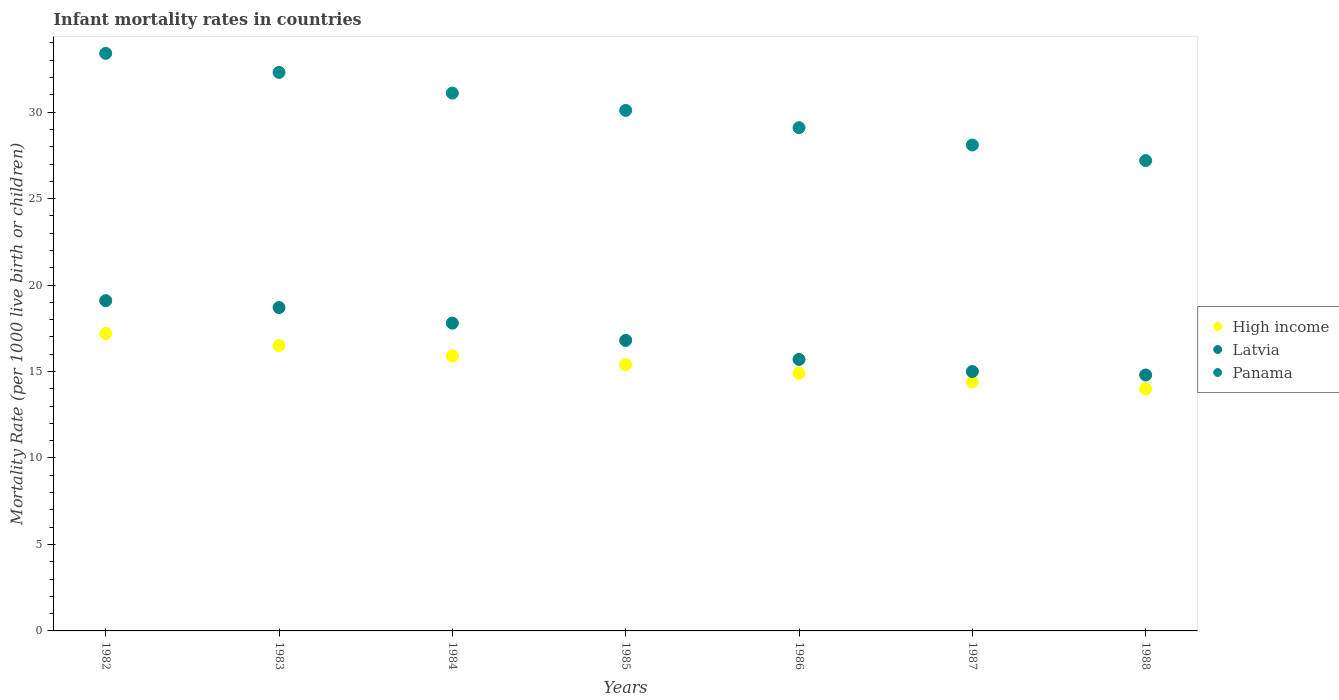What is the infant mortality rate in Latvia in 1987?
Your answer should be very brief. 15. Across all years, what is the maximum infant mortality rate in Panama?
Your response must be concise. 33.4. Across all years, what is the minimum infant mortality rate in High income?
Your response must be concise. 14. In which year was the infant mortality rate in Panama minimum?
Your answer should be very brief. 1988. What is the total infant mortality rate in Latvia in the graph?
Ensure brevity in your answer.  117.9. What is the difference between the infant mortality rate in Panama in 1982 and that in 1983?
Give a very brief answer. 1.1. What is the difference between the infant mortality rate in High income in 1984 and the infant mortality rate in Latvia in 1986?
Offer a very short reply. 0.2. What is the average infant mortality rate in High income per year?
Give a very brief answer. 15.47. What is the ratio of the infant mortality rate in Latvia in 1983 to that in 1984?
Offer a very short reply. 1.05. Is the infant mortality rate in High income in 1983 less than that in 1988?
Provide a succinct answer. No. Is the difference between the infant mortality rate in Panama in 1983 and 1984 greater than the difference between the infant mortality rate in Latvia in 1983 and 1984?
Your answer should be compact. Yes. What is the difference between the highest and the second highest infant mortality rate in Panama?
Make the answer very short. 1.1. What is the difference between the highest and the lowest infant mortality rate in Panama?
Provide a succinct answer. 6.2. In how many years, is the infant mortality rate in High income greater than the average infant mortality rate in High income taken over all years?
Offer a very short reply. 3. Is it the case that in every year, the sum of the infant mortality rate in High income and infant mortality rate in Latvia  is greater than the infant mortality rate in Panama?
Provide a succinct answer. Yes. Does the infant mortality rate in Panama monotonically increase over the years?
Provide a succinct answer. No. Is the infant mortality rate in High income strictly greater than the infant mortality rate in Latvia over the years?
Offer a very short reply. No. What is the difference between two consecutive major ticks on the Y-axis?
Ensure brevity in your answer.  5. Are the values on the major ticks of Y-axis written in scientific E-notation?
Make the answer very short. No. Does the graph contain grids?
Keep it short and to the point. No. How many legend labels are there?
Offer a terse response. 3. What is the title of the graph?
Provide a succinct answer. Infant mortality rates in countries. What is the label or title of the X-axis?
Offer a very short reply. Years. What is the label or title of the Y-axis?
Keep it short and to the point. Mortality Rate (per 1000 live birth or children). What is the Mortality Rate (per 1000 live birth or children) in Latvia in 1982?
Ensure brevity in your answer.  19.1. What is the Mortality Rate (per 1000 live birth or children) in Panama in 1982?
Offer a very short reply. 33.4. What is the Mortality Rate (per 1000 live birth or children) of High income in 1983?
Offer a very short reply. 16.5. What is the Mortality Rate (per 1000 live birth or children) in Panama in 1983?
Make the answer very short. 32.3. What is the Mortality Rate (per 1000 live birth or children) in High income in 1984?
Your answer should be compact. 15.9. What is the Mortality Rate (per 1000 live birth or children) in Panama in 1984?
Your answer should be compact. 31.1. What is the Mortality Rate (per 1000 live birth or children) in Latvia in 1985?
Ensure brevity in your answer.  16.8. What is the Mortality Rate (per 1000 live birth or children) of Panama in 1985?
Give a very brief answer. 30.1. What is the Mortality Rate (per 1000 live birth or children) in Panama in 1986?
Keep it short and to the point. 29.1. What is the Mortality Rate (per 1000 live birth or children) of High income in 1987?
Your response must be concise. 14.4. What is the Mortality Rate (per 1000 live birth or children) in Latvia in 1987?
Offer a terse response. 15. What is the Mortality Rate (per 1000 live birth or children) of Panama in 1987?
Your answer should be very brief. 28.1. What is the Mortality Rate (per 1000 live birth or children) in Latvia in 1988?
Offer a very short reply. 14.8. What is the Mortality Rate (per 1000 live birth or children) in Panama in 1988?
Your response must be concise. 27.2. Across all years, what is the maximum Mortality Rate (per 1000 live birth or children) of Panama?
Offer a terse response. 33.4. Across all years, what is the minimum Mortality Rate (per 1000 live birth or children) in Panama?
Provide a short and direct response. 27.2. What is the total Mortality Rate (per 1000 live birth or children) of High income in the graph?
Offer a very short reply. 108.3. What is the total Mortality Rate (per 1000 live birth or children) of Latvia in the graph?
Offer a very short reply. 117.9. What is the total Mortality Rate (per 1000 live birth or children) of Panama in the graph?
Your answer should be compact. 211.3. What is the difference between the Mortality Rate (per 1000 live birth or children) in High income in 1982 and that in 1984?
Give a very brief answer. 1.3. What is the difference between the Mortality Rate (per 1000 live birth or children) in Latvia in 1982 and that in 1984?
Provide a succinct answer. 1.3. What is the difference between the Mortality Rate (per 1000 live birth or children) of Panama in 1982 and that in 1984?
Provide a succinct answer. 2.3. What is the difference between the Mortality Rate (per 1000 live birth or children) in Latvia in 1982 and that in 1985?
Your response must be concise. 2.3. What is the difference between the Mortality Rate (per 1000 live birth or children) in Panama in 1982 and that in 1985?
Offer a terse response. 3.3. What is the difference between the Mortality Rate (per 1000 live birth or children) of Latvia in 1982 and that in 1986?
Your response must be concise. 3.4. What is the difference between the Mortality Rate (per 1000 live birth or children) in High income in 1982 and that in 1987?
Give a very brief answer. 2.8. What is the difference between the Mortality Rate (per 1000 live birth or children) in Panama in 1982 and that in 1987?
Offer a very short reply. 5.3. What is the difference between the Mortality Rate (per 1000 live birth or children) of High income in 1982 and that in 1988?
Make the answer very short. 3.2. What is the difference between the Mortality Rate (per 1000 live birth or children) in Panama in 1982 and that in 1988?
Your response must be concise. 6.2. What is the difference between the Mortality Rate (per 1000 live birth or children) in Latvia in 1983 and that in 1984?
Your answer should be very brief. 0.9. What is the difference between the Mortality Rate (per 1000 live birth or children) in Panama in 1983 and that in 1984?
Make the answer very short. 1.2. What is the difference between the Mortality Rate (per 1000 live birth or children) in High income in 1983 and that in 1985?
Give a very brief answer. 1.1. What is the difference between the Mortality Rate (per 1000 live birth or children) in Latvia in 1983 and that in 1985?
Your response must be concise. 1.9. What is the difference between the Mortality Rate (per 1000 live birth or children) of Panama in 1983 and that in 1985?
Offer a terse response. 2.2. What is the difference between the Mortality Rate (per 1000 live birth or children) in High income in 1983 and that in 1986?
Ensure brevity in your answer.  1.6. What is the difference between the Mortality Rate (per 1000 live birth or children) in Latvia in 1983 and that in 1986?
Make the answer very short. 3. What is the difference between the Mortality Rate (per 1000 live birth or children) of High income in 1983 and that in 1987?
Keep it short and to the point. 2.1. What is the difference between the Mortality Rate (per 1000 live birth or children) in Latvia in 1983 and that in 1987?
Ensure brevity in your answer.  3.7. What is the difference between the Mortality Rate (per 1000 live birth or children) of Panama in 1983 and that in 1987?
Your response must be concise. 4.2. What is the difference between the Mortality Rate (per 1000 live birth or children) in High income in 1984 and that in 1985?
Offer a terse response. 0.5. What is the difference between the Mortality Rate (per 1000 live birth or children) in Latvia in 1984 and that in 1985?
Your answer should be compact. 1. What is the difference between the Mortality Rate (per 1000 live birth or children) of High income in 1984 and that in 1986?
Offer a terse response. 1. What is the difference between the Mortality Rate (per 1000 live birth or children) in Latvia in 1984 and that in 1988?
Keep it short and to the point. 3. What is the difference between the Mortality Rate (per 1000 live birth or children) in Latvia in 1985 and that in 1987?
Provide a short and direct response. 1.8. What is the difference between the Mortality Rate (per 1000 live birth or children) of Latvia in 1985 and that in 1988?
Ensure brevity in your answer.  2. What is the difference between the Mortality Rate (per 1000 live birth or children) in Panama in 1985 and that in 1988?
Provide a succinct answer. 2.9. What is the difference between the Mortality Rate (per 1000 live birth or children) of High income in 1986 and that in 1987?
Your response must be concise. 0.5. What is the difference between the Mortality Rate (per 1000 live birth or children) of Latvia in 1986 and that in 1987?
Your response must be concise. 0.7. What is the difference between the Mortality Rate (per 1000 live birth or children) in Panama in 1986 and that in 1987?
Offer a terse response. 1. What is the difference between the Mortality Rate (per 1000 live birth or children) in High income in 1986 and that in 1988?
Your answer should be very brief. 0.9. What is the difference between the Mortality Rate (per 1000 live birth or children) in Latvia in 1986 and that in 1988?
Offer a very short reply. 0.9. What is the difference between the Mortality Rate (per 1000 live birth or children) in High income in 1987 and that in 1988?
Offer a very short reply. 0.4. What is the difference between the Mortality Rate (per 1000 live birth or children) in Latvia in 1987 and that in 1988?
Offer a terse response. 0.2. What is the difference between the Mortality Rate (per 1000 live birth or children) of Panama in 1987 and that in 1988?
Give a very brief answer. 0.9. What is the difference between the Mortality Rate (per 1000 live birth or children) of High income in 1982 and the Mortality Rate (per 1000 live birth or children) of Latvia in 1983?
Your response must be concise. -1.5. What is the difference between the Mortality Rate (per 1000 live birth or children) of High income in 1982 and the Mortality Rate (per 1000 live birth or children) of Panama in 1983?
Provide a short and direct response. -15.1. What is the difference between the Mortality Rate (per 1000 live birth or children) in Latvia in 1982 and the Mortality Rate (per 1000 live birth or children) in Panama in 1983?
Give a very brief answer. -13.2. What is the difference between the Mortality Rate (per 1000 live birth or children) in High income in 1982 and the Mortality Rate (per 1000 live birth or children) in Latvia in 1984?
Give a very brief answer. -0.6. What is the difference between the Mortality Rate (per 1000 live birth or children) of High income in 1982 and the Mortality Rate (per 1000 live birth or children) of Latvia in 1985?
Your answer should be compact. 0.4. What is the difference between the Mortality Rate (per 1000 live birth or children) of High income in 1982 and the Mortality Rate (per 1000 live birth or children) of Panama in 1985?
Offer a very short reply. -12.9. What is the difference between the Mortality Rate (per 1000 live birth or children) of Latvia in 1982 and the Mortality Rate (per 1000 live birth or children) of Panama in 1985?
Ensure brevity in your answer.  -11. What is the difference between the Mortality Rate (per 1000 live birth or children) of High income in 1982 and the Mortality Rate (per 1000 live birth or children) of Latvia in 1986?
Your answer should be very brief. 1.5. What is the difference between the Mortality Rate (per 1000 live birth or children) of High income in 1982 and the Mortality Rate (per 1000 live birth or children) of Latvia in 1987?
Your answer should be compact. 2.2. What is the difference between the Mortality Rate (per 1000 live birth or children) of High income in 1982 and the Mortality Rate (per 1000 live birth or children) of Panama in 1987?
Provide a short and direct response. -10.9. What is the difference between the Mortality Rate (per 1000 live birth or children) in Latvia in 1982 and the Mortality Rate (per 1000 live birth or children) in Panama in 1987?
Provide a succinct answer. -9. What is the difference between the Mortality Rate (per 1000 live birth or children) in High income in 1983 and the Mortality Rate (per 1000 live birth or children) in Latvia in 1984?
Give a very brief answer. -1.3. What is the difference between the Mortality Rate (per 1000 live birth or children) in High income in 1983 and the Mortality Rate (per 1000 live birth or children) in Panama in 1984?
Give a very brief answer. -14.6. What is the difference between the Mortality Rate (per 1000 live birth or children) of High income in 1983 and the Mortality Rate (per 1000 live birth or children) of Latvia in 1985?
Provide a succinct answer. -0.3. What is the difference between the Mortality Rate (per 1000 live birth or children) of Latvia in 1983 and the Mortality Rate (per 1000 live birth or children) of Panama in 1985?
Provide a short and direct response. -11.4. What is the difference between the Mortality Rate (per 1000 live birth or children) of Latvia in 1983 and the Mortality Rate (per 1000 live birth or children) of Panama in 1986?
Your answer should be very brief. -10.4. What is the difference between the Mortality Rate (per 1000 live birth or children) in High income in 1983 and the Mortality Rate (per 1000 live birth or children) in Panama in 1987?
Your response must be concise. -11.6. What is the difference between the Mortality Rate (per 1000 live birth or children) in Latvia in 1983 and the Mortality Rate (per 1000 live birth or children) in Panama in 1987?
Ensure brevity in your answer.  -9.4. What is the difference between the Mortality Rate (per 1000 live birth or children) in High income in 1983 and the Mortality Rate (per 1000 live birth or children) in Latvia in 1988?
Give a very brief answer. 1.7. What is the difference between the Mortality Rate (per 1000 live birth or children) in High income in 1983 and the Mortality Rate (per 1000 live birth or children) in Panama in 1988?
Your response must be concise. -10.7. What is the difference between the Mortality Rate (per 1000 live birth or children) of High income in 1984 and the Mortality Rate (per 1000 live birth or children) of Panama in 1985?
Make the answer very short. -14.2. What is the difference between the Mortality Rate (per 1000 live birth or children) of Latvia in 1984 and the Mortality Rate (per 1000 live birth or children) of Panama in 1985?
Keep it short and to the point. -12.3. What is the difference between the Mortality Rate (per 1000 live birth or children) in High income in 1984 and the Mortality Rate (per 1000 live birth or children) in Panama in 1986?
Keep it short and to the point. -13.2. What is the difference between the Mortality Rate (per 1000 live birth or children) of High income in 1984 and the Mortality Rate (per 1000 live birth or children) of Panama in 1987?
Your answer should be very brief. -12.2. What is the difference between the Mortality Rate (per 1000 live birth or children) of High income in 1984 and the Mortality Rate (per 1000 live birth or children) of Latvia in 1988?
Offer a very short reply. 1.1. What is the difference between the Mortality Rate (per 1000 live birth or children) of High income in 1985 and the Mortality Rate (per 1000 live birth or children) of Panama in 1986?
Give a very brief answer. -13.7. What is the difference between the Mortality Rate (per 1000 live birth or children) of High income in 1985 and the Mortality Rate (per 1000 live birth or children) of Latvia in 1987?
Offer a very short reply. 0.4. What is the difference between the Mortality Rate (per 1000 live birth or children) of Latvia in 1985 and the Mortality Rate (per 1000 live birth or children) of Panama in 1988?
Offer a very short reply. -10.4. What is the difference between the Mortality Rate (per 1000 live birth or children) of High income in 1986 and the Mortality Rate (per 1000 live birth or children) of Panama in 1987?
Offer a very short reply. -13.2. What is the difference between the Mortality Rate (per 1000 live birth or children) in Latvia in 1986 and the Mortality Rate (per 1000 live birth or children) in Panama in 1987?
Offer a terse response. -12.4. What is the difference between the Mortality Rate (per 1000 live birth or children) of High income in 1986 and the Mortality Rate (per 1000 live birth or children) of Panama in 1988?
Offer a terse response. -12.3. What is the difference between the Mortality Rate (per 1000 live birth or children) of High income in 1987 and the Mortality Rate (per 1000 live birth or children) of Latvia in 1988?
Make the answer very short. -0.4. What is the difference between the Mortality Rate (per 1000 live birth or children) of Latvia in 1987 and the Mortality Rate (per 1000 live birth or children) of Panama in 1988?
Offer a terse response. -12.2. What is the average Mortality Rate (per 1000 live birth or children) of High income per year?
Make the answer very short. 15.47. What is the average Mortality Rate (per 1000 live birth or children) of Latvia per year?
Your answer should be very brief. 16.84. What is the average Mortality Rate (per 1000 live birth or children) of Panama per year?
Offer a very short reply. 30.19. In the year 1982, what is the difference between the Mortality Rate (per 1000 live birth or children) in High income and Mortality Rate (per 1000 live birth or children) in Panama?
Provide a short and direct response. -16.2. In the year 1982, what is the difference between the Mortality Rate (per 1000 live birth or children) of Latvia and Mortality Rate (per 1000 live birth or children) of Panama?
Keep it short and to the point. -14.3. In the year 1983, what is the difference between the Mortality Rate (per 1000 live birth or children) of High income and Mortality Rate (per 1000 live birth or children) of Latvia?
Your answer should be compact. -2.2. In the year 1983, what is the difference between the Mortality Rate (per 1000 live birth or children) of High income and Mortality Rate (per 1000 live birth or children) of Panama?
Offer a terse response. -15.8. In the year 1984, what is the difference between the Mortality Rate (per 1000 live birth or children) of High income and Mortality Rate (per 1000 live birth or children) of Latvia?
Offer a very short reply. -1.9. In the year 1984, what is the difference between the Mortality Rate (per 1000 live birth or children) in High income and Mortality Rate (per 1000 live birth or children) in Panama?
Offer a very short reply. -15.2. In the year 1985, what is the difference between the Mortality Rate (per 1000 live birth or children) of High income and Mortality Rate (per 1000 live birth or children) of Latvia?
Offer a terse response. -1.4. In the year 1985, what is the difference between the Mortality Rate (per 1000 live birth or children) in High income and Mortality Rate (per 1000 live birth or children) in Panama?
Make the answer very short. -14.7. In the year 1985, what is the difference between the Mortality Rate (per 1000 live birth or children) of Latvia and Mortality Rate (per 1000 live birth or children) of Panama?
Give a very brief answer. -13.3. In the year 1986, what is the difference between the Mortality Rate (per 1000 live birth or children) of High income and Mortality Rate (per 1000 live birth or children) of Latvia?
Provide a succinct answer. -0.8. In the year 1986, what is the difference between the Mortality Rate (per 1000 live birth or children) of Latvia and Mortality Rate (per 1000 live birth or children) of Panama?
Ensure brevity in your answer.  -13.4. In the year 1987, what is the difference between the Mortality Rate (per 1000 live birth or children) in High income and Mortality Rate (per 1000 live birth or children) in Latvia?
Offer a terse response. -0.6. In the year 1987, what is the difference between the Mortality Rate (per 1000 live birth or children) in High income and Mortality Rate (per 1000 live birth or children) in Panama?
Your response must be concise. -13.7. In the year 1987, what is the difference between the Mortality Rate (per 1000 live birth or children) in Latvia and Mortality Rate (per 1000 live birth or children) in Panama?
Offer a terse response. -13.1. In the year 1988, what is the difference between the Mortality Rate (per 1000 live birth or children) of High income and Mortality Rate (per 1000 live birth or children) of Latvia?
Give a very brief answer. -0.8. In the year 1988, what is the difference between the Mortality Rate (per 1000 live birth or children) of Latvia and Mortality Rate (per 1000 live birth or children) of Panama?
Your answer should be very brief. -12.4. What is the ratio of the Mortality Rate (per 1000 live birth or children) of High income in 1982 to that in 1983?
Your answer should be compact. 1.04. What is the ratio of the Mortality Rate (per 1000 live birth or children) of Latvia in 1982 to that in 1983?
Give a very brief answer. 1.02. What is the ratio of the Mortality Rate (per 1000 live birth or children) of Panama in 1982 to that in 1983?
Provide a short and direct response. 1.03. What is the ratio of the Mortality Rate (per 1000 live birth or children) of High income in 1982 to that in 1984?
Ensure brevity in your answer.  1.08. What is the ratio of the Mortality Rate (per 1000 live birth or children) in Latvia in 1982 to that in 1984?
Provide a short and direct response. 1.07. What is the ratio of the Mortality Rate (per 1000 live birth or children) in Panama in 1982 to that in 1984?
Provide a succinct answer. 1.07. What is the ratio of the Mortality Rate (per 1000 live birth or children) in High income in 1982 to that in 1985?
Your answer should be compact. 1.12. What is the ratio of the Mortality Rate (per 1000 live birth or children) of Latvia in 1982 to that in 1985?
Offer a very short reply. 1.14. What is the ratio of the Mortality Rate (per 1000 live birth or children) of Panama in 1982 to that in 1985?
Provide a short and direct response. 1.11. What is the ratio of the Mortality Rate (per 1000 live birth or children) of High income in 1982 to that in 1986?
Offer a terse response. 1.15. What is the ratio of the Mortality Rate (per 1000 live birth or children) of Latvia in 1982 to that in 1986?
Provide a succinct answer. 1.22. What is the ratio of the Mortality Rate (per 1000 live birth or children) of Panama in 1982 to that in 1986?
Your response must be concise. 1.15. What is the ratio of the Mortality Rate (per 1000 live birth or children) in High income in 1982 to that in 1987?
Provide a succinct answer. 1.19. What is the ratio of the Mortality Rate (per 1000 live birth or children) in Latvia in 1982 to that in 1987?
Your answer should be compact. 1.27. What is the ratio of the Mortality Rate (per 1000 live birth or children) of Panama in 1982 to that in 1987?
Make the answer very short. 1.19. What is the ratio of the Mortality Rate (per 1000 live birth or children) in High income in 1982 to that in 1988?
Give a very brief answer. 1.23. What is the ratio of the Mortality Rate (per 1000 live birth or children) of Latvia in 1982 to that in 1988?
Give a very brief answer. 1.29. What is the ratio of the Mortality Rate (per 1000 live birth or children) in Panama in 1982 to that in 1988?
Provide a short and direct response. 1.23. What is the ratio of the Mortality Rate (per 1000 live birth or children) of High income in 1983 to that in 1984?
Ensure brevity in your answer.  1.04. What is the ratio of the Mortality Rate (per 1000 live birth or children) of Latvia in 1983 to that in 1984?
Your answer should be compact. 1.05. What is the ratio of the Mortality Rate (per 1000 live birth or children) of Panama in 1983 to that in 1984?
Your answer should be compact. 1.04. What is the ratio of the Mortality Rate (per 1000 live birth or children) of High income in 1983 to that in 1985?
Your answer should be compact. 1.07. What is the ratio of the Mortality Rate (per 1000 live birth or children) of Latvia in 1983 to that in 1985?
Offer a very short reply. 1.11. What is the ratio of the Mortality Rate (per 1000 live birth or children) of Panama in 1983 to that in 1985?
Your answer should be very brief. 1.07. What is the ratio of the Mortality Rate (per 1000 live birth or children) of High income in 1983 to that in 1986?
Your answer should be very brief. 1.11. What is the ratio of the Mortality Rate (per 1000 live birth or children) in Latvia in 1983 to that in 1986?
Provide a short and direct response. 1.19. What is the ratio of the Mortality Rate (per 1000 live birth or children) in Panama in 1983 to that in 1986?
Your answer should be very brief. 1.11. What is the ratio of the Mortality Rate (per 1000 live birth or children) in High income in 1983 to that in 1987?
Keep it short and to the point. 1.15. What is the ratio of the Mortality Rate (per 1000 live birth or children) of Latvia in 1983 to that in 1987?
Provide a succinct answer. 1.25. What is the ratio of the Mortality Rate (per 1000 live birth or children) in Panama in 1983 to that in 1987?
Offer a very short reply. 1.15. What is the ratio of the Mortality Rate (per 1000 live birth or children) of High income in 1983 to that in 1988?
Your response must be concise. 1.18. What is the ratio of the Mortality Rate (per 1000 live birth or children) in Latvia in 1983 to that in 1988?
Offer a terse response. 1.26. What is the ratio of the Mortality Rate (per 1000 live birth or children) in Panama in 1983 to that in 1988?
Keep it short and to the point. 1.19. What is the ratio of the Mortality Rate (per 1000 live birth or children) in High income in 1984 to that in 1985?
Offer a terse response. 1.03. What is the ratio of the Mortality Rate (per 1000 live birth or children) of Latvia in 1984 to that in 1985?
Your answer should be very brief. 1.06. What is the ratio of the Mortality Rate (per 1000 live birth or children) of Panama in 1984 to that in 1985?
Keep it short and to the point. 1.03. What is the ratio of the Mortality Rate (per 1000 live birth or children) of High income in 1984 to that in 1986?
Offer a terse response. 1.07. What is the ratio of the Mortality Rate (per 1000 live birth or children) of Latvia in 1984 to that in 1986?
Offer a very short reply. 1.13. What is the ratio of the Mortality Rate (per 1000 live birth or children) of Panama in 1984 to that in 1986?
Your answer should be very brief. 1.07. What is the ratio of the Mortality Rate (per 1000 live birth or children) in High income in 1984 to that in 1987?
Offer a very short reply. 1.1. What is the ratio of the Mortality Rate (per 1000 live birth or children) in Latvia in 1984 to that in 1987?
Offer a very short reply. 1.19. What is the ratio of the Mortality Rate (per 1000 live birth or children) of Panama in 1984 to that in 1987?
Offer a very short reply. 1.11. What is the ratio of the Mortality Rate (per 1000 live birth or children) of High income in 1984 to that in 1988?
Your answer should be compact. 1.14. What is the ratio of the Mortality Rate (per 1000 live birth or children) of Latvia in 1984 to that in 1988?
Offer a terse response. 1.2. What is the ratio of the Mortality Rate (per 1000 live birth or children) in Panama in 1984 to that in 1988?
Your response must be concise. 1.14. What is the ratio of the Mortality Rate (per 1000 live birth or children) in High income in 1985 to that in 1986?
Give a very brief answer. 1.03. What is the ratio of the Mortality Rate (per 1000 live birth or children) in Latvia in 1985 to that in 1986?
Your answer should be compact. 1.07. What is the ratio of the Mortality Rate (per 1000 live birth or children) of Panama in 1985 to that in 1986?
Your response must be concise. 1.03. What is the ratio of the Mortality Rate (per 1000 live birth or children) of High income in 1985 to that in 1987?
Provide a succinct answer. 1.07. What is the ratio of the Mortality Rate (per 1000 live birth or children) in Latvia in 1985 to that in 1987?
Ensure brevity in your answer.  1.12. What is the ratio of the Mortality Rate (per 1000 live birth or children) in Panama in 1985 to that in 1987?
Provide a succinct answer. 1.07. What is the ratio of the Mortality Rate (per 1000 live birth or children) of High income in 1985 to that in 1988?
Make the answer very short. 1.1. What is the ratio of the Mortality Rate (per 1000 live birth or children) in Latvia in 1985 to that in 1988?
Your answer should be compact. 1.14. What is the ratio of the Mortality Rate (per 1000 live birth or children) in Panama in 1985 to that in 1988?
Make the answer very short. 1.11. What is the ratio of the Mortality Rate (per 1000 live birth or children) of High income in 1986 to that in 1987?
Your answer should be compact. 1.03. What is the ratio of the Mortality Rate (per 1000 live birth or children) in Latvia in 1986 to that in 1987?
Your answer should be very brief. 1.05. What is the ratio of the Mortality Rate (per 1000 live birth or children) of Panama in 1986 to that in 1987?
Make the answer very short. 1.04. What is the ratio of the Mortality Rate (per 1000 live birth or children) in High income in 1986 to that in 1988?
Make the answer very short. 1.06. What is the ratio of the Mortality Rate (per 1000 live birth or children) in Latvia in 1986 to that in 1988?
Keep it short and to the point. 1.06. What is the ratio of the Mortality Rate (per 1000 live birth or children) of Panama in 1986 to that in 1988?
Your answer should be compact. 1.07. What is the ratio of the Mortality Rate (per 1000 live birth or children) of High income in 1987 to that in 1988?
Ensure brevity in your answer.  1.03. What is the ratio of the Mortality Rate (per 1000 live birth or children) in Latvia in 1987 to that in 1988?
Your answer should be very brief. 1.01. What is the ratio of the Mortality Rate (per 1000 live birth or children) of Panama in 1987 to that in 1988?
Keep it short and to the point. 1.03. What is the difference between the highest and the second highest Mortality Rate (per 1000 live birth or children) of Panama?
Ensure brevity in your answer.  1.1. What is the difference between the highest and the lowest Mortality Rate (per 1000 live birth or children) of High income?
Give a very brief answer. 3.2. What is the difference between the highest and the lowest Mortality Rate (per 1000 live birth or children) of Latvia?
Provide a succinct answer. 4.3. 